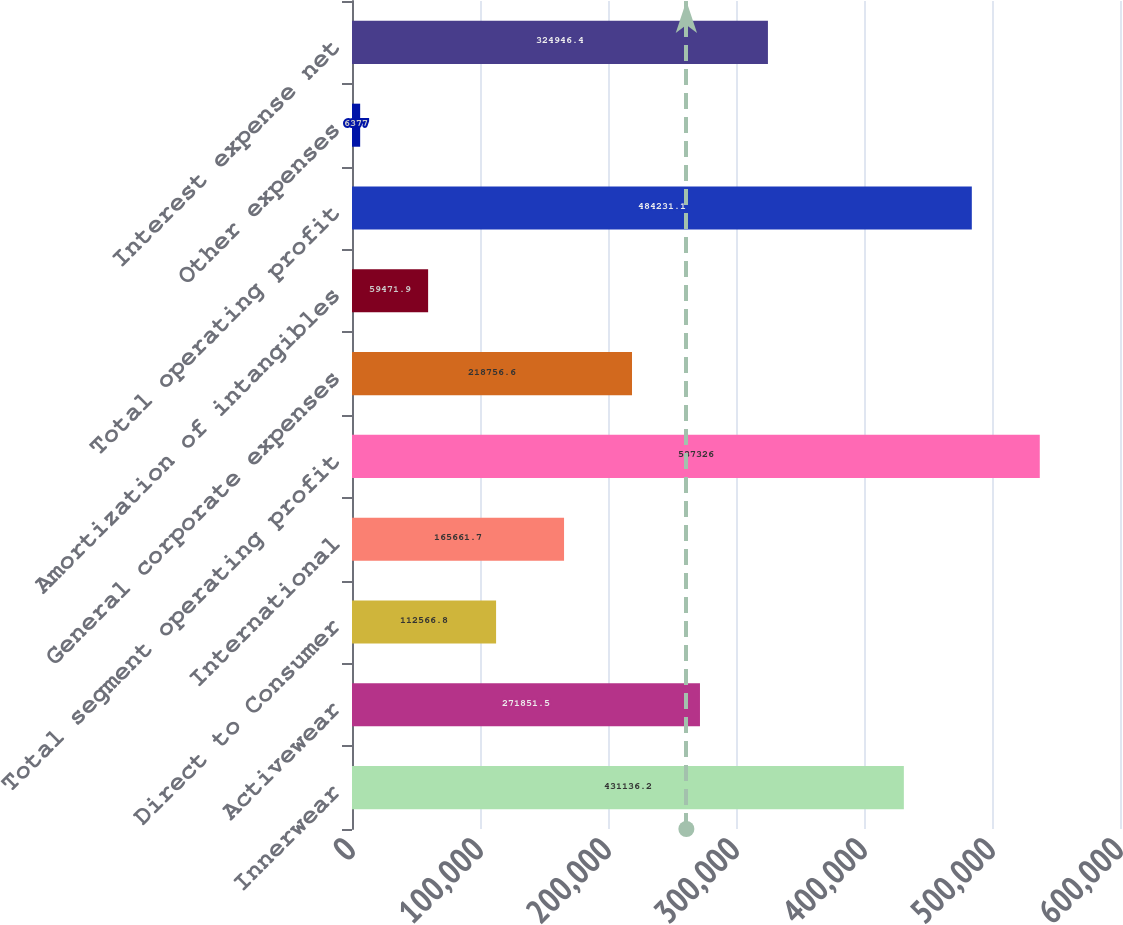<chart> <loc_0><loc_0><loc_500><loc_500><bar_chart><fcel>Innerwear<fcel>Activewear<fcel>Direct to Consumer<fcel>International<fcel>Total segment operating profit<fcel>General corporate expenses<fcel>Amortization of intangibles<fcel>Total operating profit<fcel>Other expenses<fcel>Interest expense net<nl><fcel>431136<fcel>271852<fcel>112567<fcel>165662<fcel>537326<fcel>218757<fcel>59471.9<fcel>484231<fcel>6377<fcel>324946<nl></chart> 